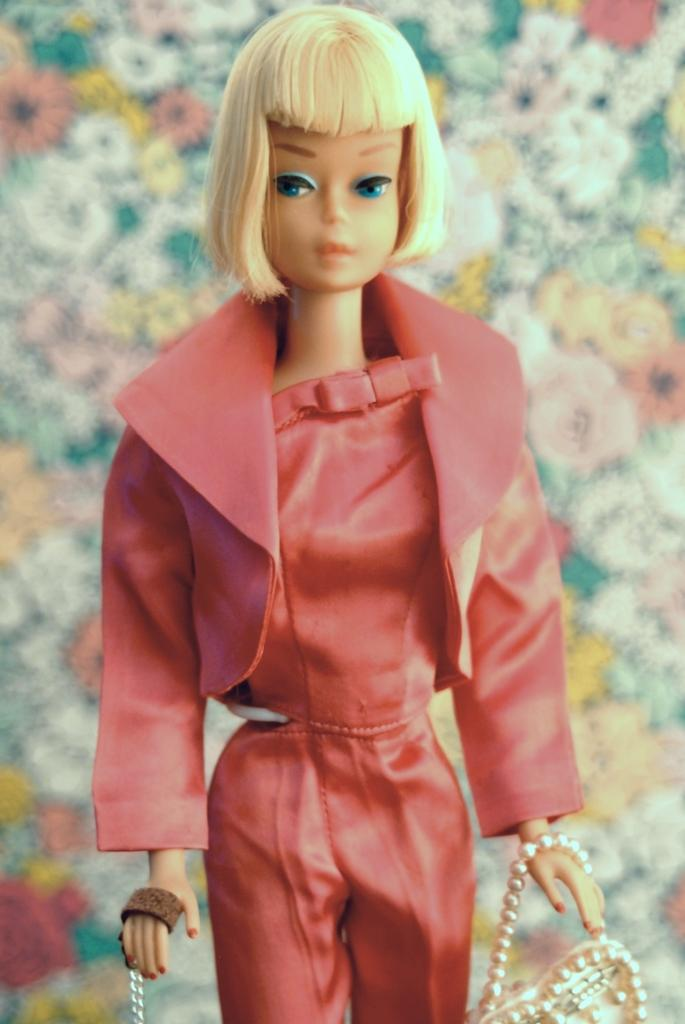What is the main subject of the image? There is a doll in the image. What is the doll wearing? The doll is wearing a red jacket and red pants. What is the doll holding in its right hand? The doll has a handbag in its right hand. What is the doll holding in its left hand? The doll has a chain in its left hand. How many pages are in the doll's underwear in the image? There is no mention of pages or underwear in the image; the doll is wearing a red jacket and red pants, and holding a handbag and a chain. 